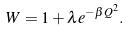<formula> <loc_0><loc_0><loc_500><loc_500>W = 1 + \lambda e ^ { - \beta Q ^ { 2 } } .</formula> 